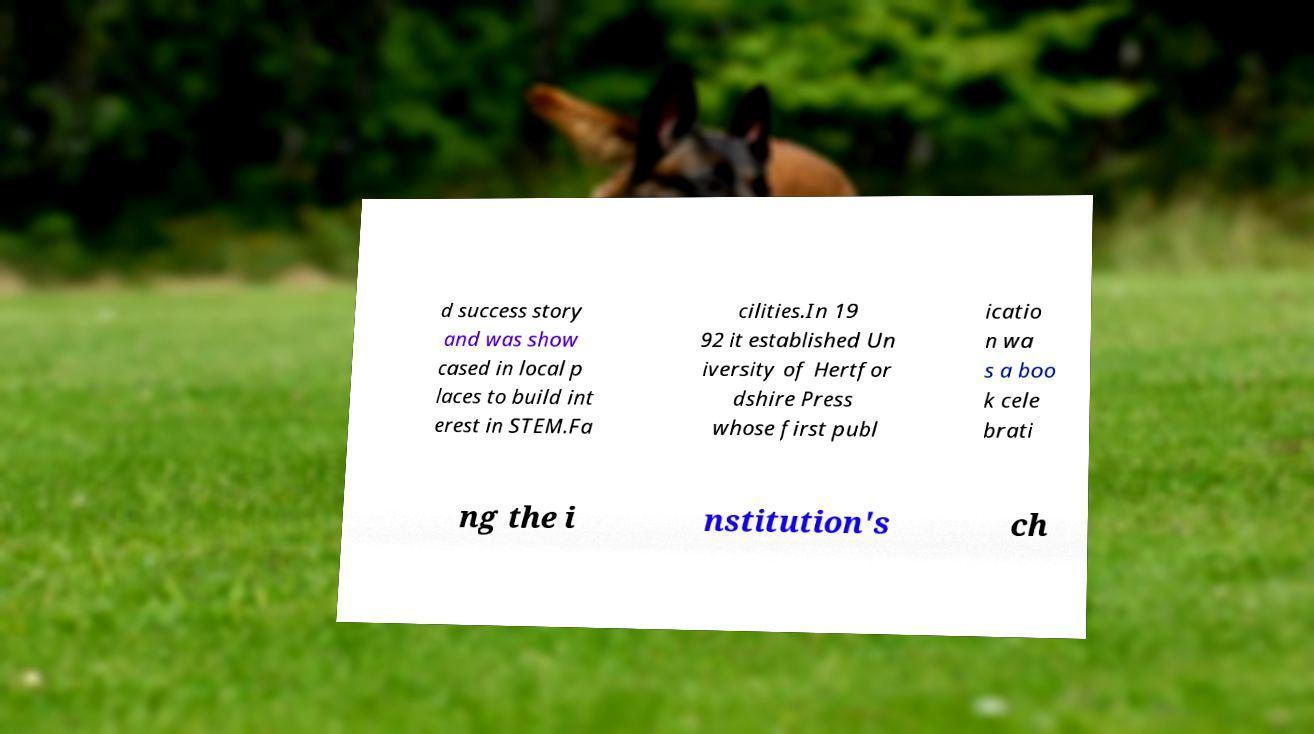Can you accurately transcribe the text from the provided image for me? d success story and was show cased in local p laces to build int erest in STEM.Fa cilities.In 19 92 it established Un iversity of Hertfor dshire Press whose first publ icatio n wa s a boo k cele brati ng the i nstitution's ch 